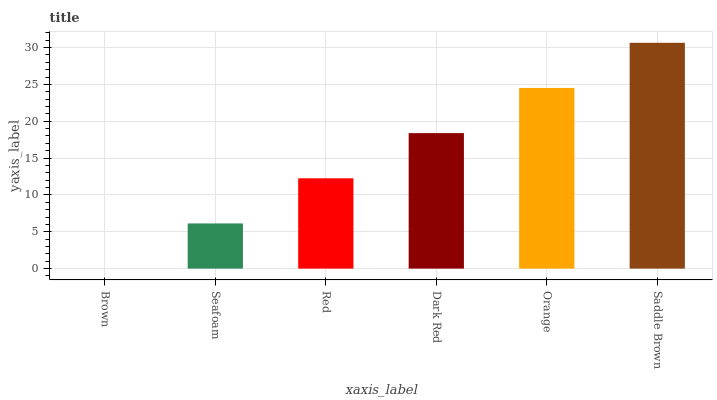Is Seafoam the minimum?
Answer yes or no. No. Is Seafoam the maximum?
Answer yes or no. No. Is Seafoam greater than Brown?
Answer yes or no. Yes. Is Brown less than Seafoam?
Answer yes or no. Yes. Is Brown greater than Seafoam?
Answer yes or no. No. Is Seafoam less than Brown?
Answer yes or no. No. Is Dark Red the high median?
Answer yes or no. Yes. Is Red the low median?
Answer yes or no. Yes. Is Saddle Brown the high median?
Answer yes or no. No. Is Dark Red the low median?
Answer yes or no. No. 